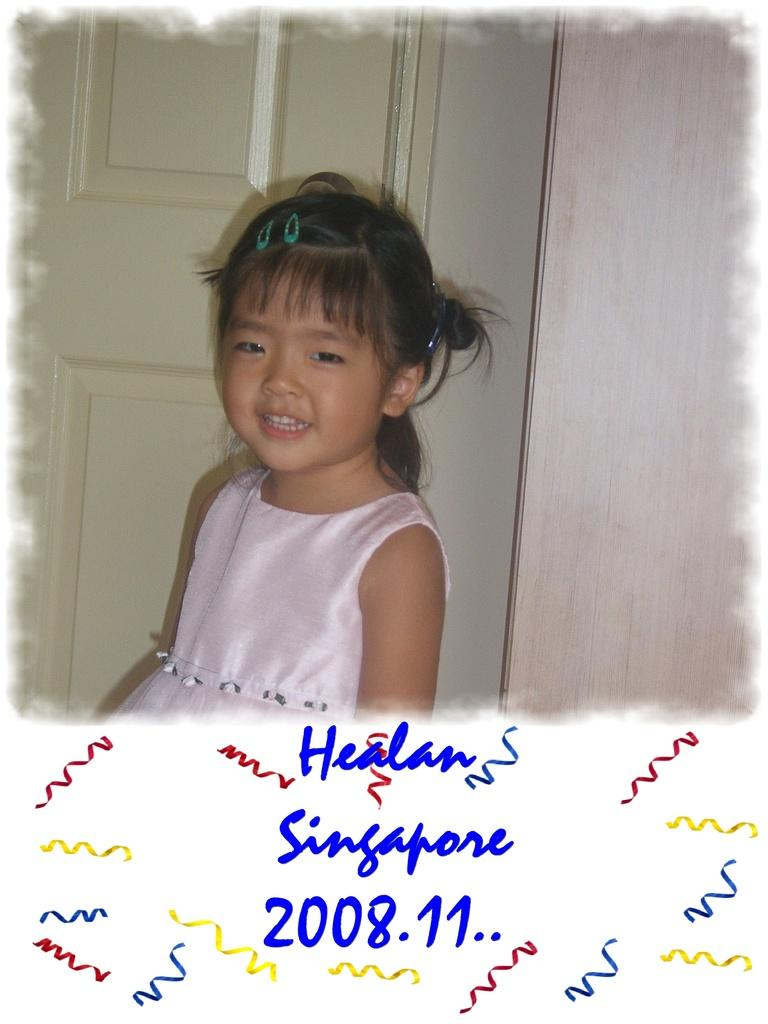Who is the main subject in the image? There is a girl in the image. Where is the girl located in the image? The girl is at the top of the image. What is behind the girl in the image? There is a door behind the girl. What can be found at the bottom of the image? There is text at the bottom of the image, along with other unspecified elements. What type of glass is being used for the meal in the image? There is no meal or glass present in the image. What is the condition of the roof in the image? There is no roof visible in the image; it only shows a girl, a door, text, and other unspecified elements at the bottom. 